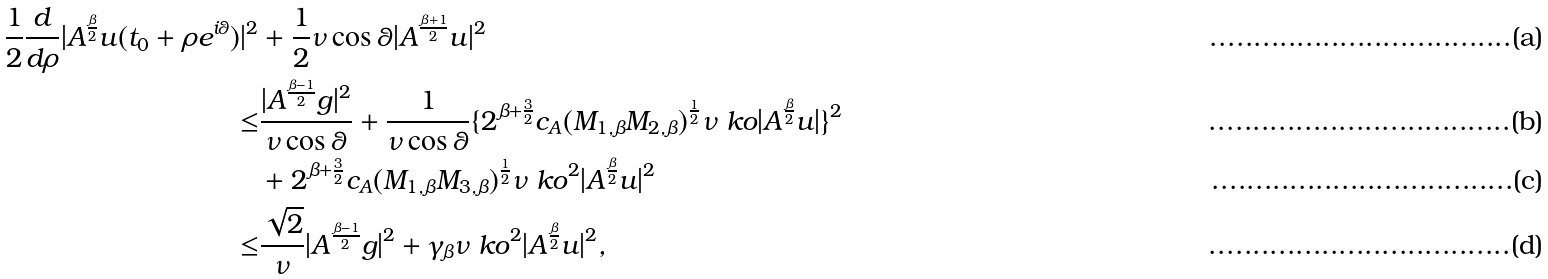Convert formula to latex. <formula><loc_0><loc_0><loc_500><loc_500>\frac { 1 } { 2 } \frac { d } { d \rho } | A ^ { \frac { \beta } { 2 } } u ( t _ { 0 } + \rho e ^ { i \theta } ) | ^ { 2 } & + \frac { 1 } { 2 } \nu \cos \theta | A ^ { \frac { \beta + 1 } { 2 } } u | ^ { 2 } \\ \leq & \frac { | A ^ { \frac { \beta - 1 } { 2 } } g | ^ { 2 } } { \nu \cos \theta } + \frac { 1 } { \nu \cos \theta } \{ { 2 ^ { \beta + \frac { 3 } { 2 } } c _ { A } } ( M _ { 1 , \beta } M _ { 2 , \beta } ) ^ { \frac { 1 } { 2 } } \nu \ k o | A ^ { \frac { \beta } { 2 } } { u } | \} ^ { 2 } \\ & + { 2 ^ { \beta + \frac { 3 } { 2 } } c _ { A } } ( M _ { 1 , \beta } M _ { 3 , \beta } ) ^ { \frac { 1 } { 2 } } \nu \ k o ^ { 2 } | A ^ { \frac { \beta } { 2 } } { u } | ^ { 2 } \\ \leq & \frac { \sqrt { 2 } } { \nu } | A ^ { \frac { \beta - 1 } { 2 } } g | ^ { 2 } + \gamma _ { \beta } \nu \ k o ^ { 2 } | A ^ { \frac { \beta } { 2 } } { u } | ^ { 2 } ,</formula> 